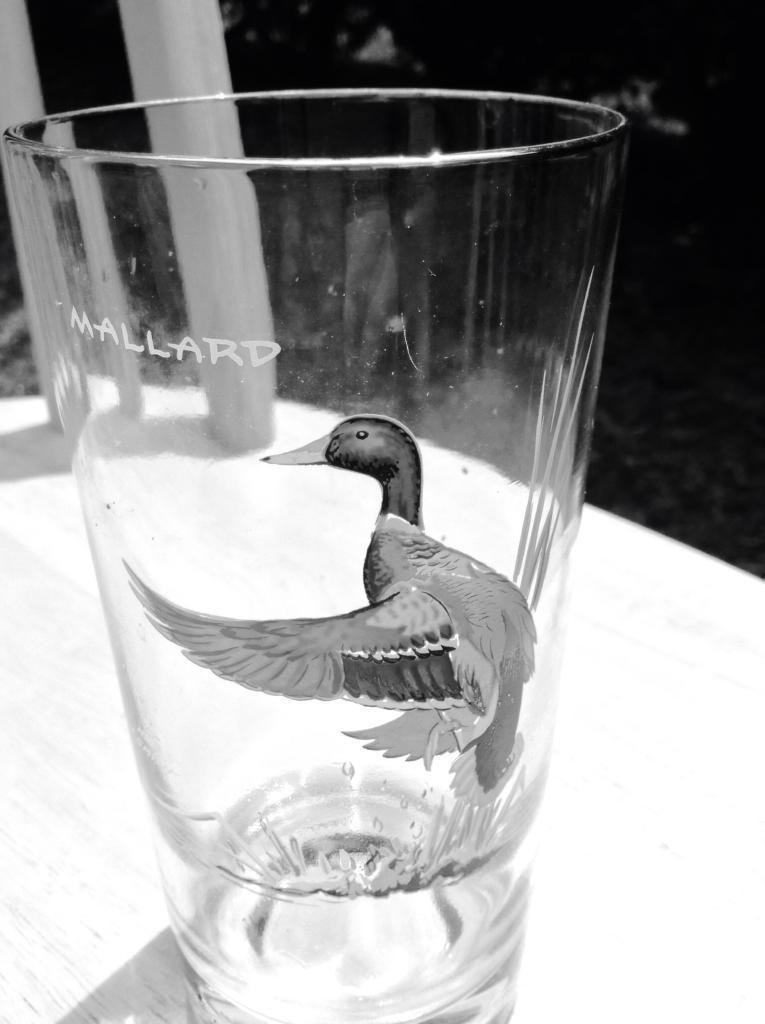Describe this image in one or two sentences. In this picture i can see a glass which has a design on it. The glass is on a table. This picture is black and white in color. 